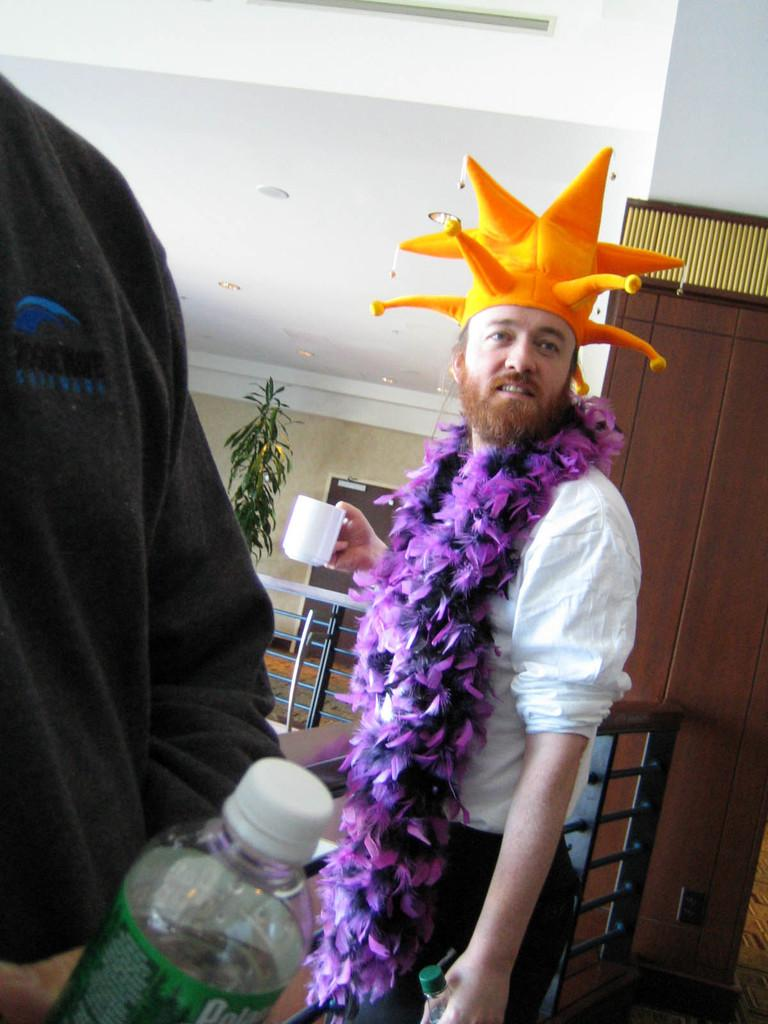What is the man in the image holding in his hands? The man is holding a bottle and a cup in the image. What is the man wearing on his head? The man is wearing a hat in the image. How many people are present in the image? There are two people in the image. What is the other person holding in their hands? The other person is holding a bottle in the image. What type of sofa can be seen in the background of the image? There is no sofa present in the image; it features a man holding a bottle and a cup, wearing a hat, and standing next to another person holding a bottle. 